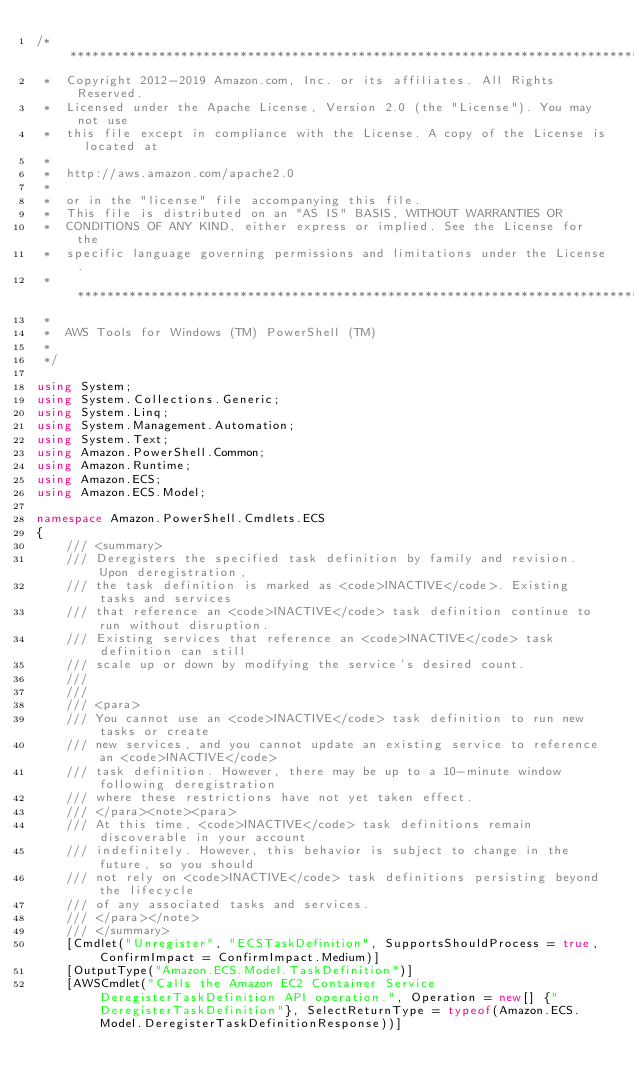<code> <loc_0><loc_0><loc_500><loc_500><_C#_>/*******************************************************************************
 *  Copyright 2012-2019 Amazon.com, Inc. or its affiliates. All Rights Reserved.
 *  Licensed under the Apache License, Version 2.0 (the "License"). You may not use
 *  this file except in compliance with the License. A copy of the License is located at
 *
 *  http://aws.amazon.com/apache2.0
 *
 *  or in the "license" file accompanying this file.
 *  This file is distributed on an "AS IS" BASIS, WITHOUT WARRANTIES OR
 *  CONDITIONS OF ANY KIND, either express or implied. See the License for the
 *  specific language governing permissions and limitations under the License.
 * *****************************************************************************
 *
 *  AWS Tools for Windows (TM) PowerShell (TM)
 *
 */

using System;
using System.Collections.Generic;
using System.Linq;
using System.Management.Automation;
using System.Text;
using Amazon.PowerShell.Common;
using Amazon.Runtime;
using Amazon.ECS;
using Amazon.ECS.Model;

namespace Amazon.PowerShell.Cmdlets.ECS
{
    /// <summary>
    /// Deregisters the specified task definition by family and revision. Upon deregistration,
    /// the task definition is marked as <code>INACTIVE</code>. Existing tasks and services
    /// that reference an <code>INACTIVE</code> task definition continue to run without disruption.
    /// Existing services that reference an <code>INACTIVE</code> task definition can still
    /// scale up or down by modifying the service's desired count.
    /// 
    ///  
    /// <para>
    /// You cannot use an <code>INACTIVE</code> task definition to run new tasks or create
    /// new services, and you cannot update an existing service to reference an <code>INACTIVE</code>
    /// task definition. However, there may be up to a 10-minute window following deregistration
    /// where these restrictions have not yet taken effect.
    /// </para><note><para>
    /// At this time, <code>INACTIVE</code> task definitions remain discoverable in your account
    /// indefinitely. However, this behavior is subject to change in the future, so you should
    /// not rely on <code>INACTIVE</code> task definitions persisting beyond the lifecycle
    /// of any associated tasks and services.
    /// </para></note>
    /// </summary>
    [Cmdlet("Unregister", "ECSTaskDefinition", SupportsShouldProcess = true, ConfirmImpact = ConfirmImpact.Medium)]
    [OutputType("Amazon.ECS.Model.TaskDefinition")]
    [AWSCmdlet("Calls the Amazon EC2 Container Service DeregisterTaskDefinition API operation.", Operation = new[] {"DeregisterTaskDefinition"}, SelectReturnType = typeof(Amazon.ECS.Model.DeregisterTaskDefinitionResponse))]</code> 